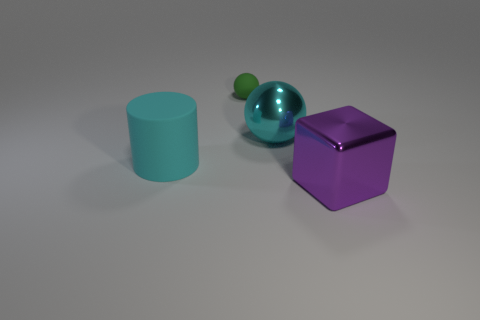Do the large purple cube right of the green rubber thing and the cyan thing right of the matte ball have the same material?
Your response must be concise. Yes. What is the shape of the purple metallic thing that is the same size as the cyan cylinder?
Provide a succinct answer. Cube. What number of other objects are the same color as the big cylinder?
Provide a succinct answer. 1. There is a thing that is on the left side of the green rubber sphere; what color is it?
Your answer should be compact. Cyan. What number of other objects are the same material as the large sphere?
Give a very brief answer. 1. Is the number of big rubber cylinders that are right of the green matte sphere greater than the number of large objects to the right of the large purple shiny cube?
Make the answer very short. No. There is a large shiny ball; what number of large objects are left of it?
Provide a short and direct response. 1. Does the block have the same material as the sphere to the right of the tiny green matte ball?
Make the answer very short. Yes. Is there any other thing that is the same shape as the small green rubber object?
Offer a terse response. Yes. Does the block have the same material as the cyan ball?
Your response must be concise. Yes. 